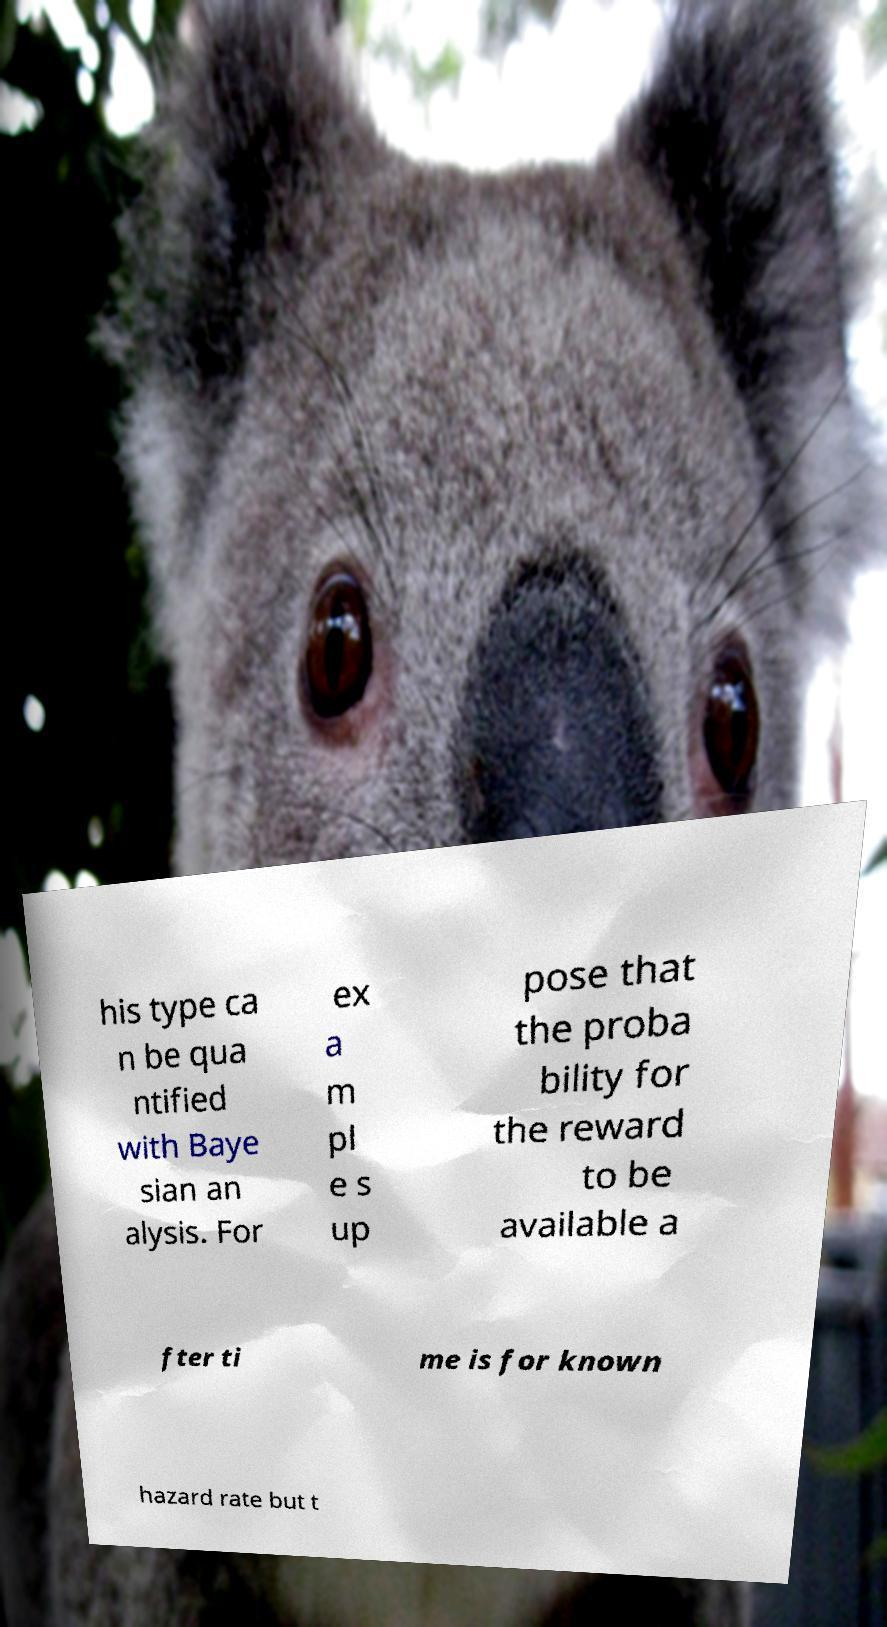I need the written content from this picture converted into text. Can you do that? his type ca n be qua ntified with Baye sian an alysis. For ex a m pl e s up pose that the proba bility for the reward to be available a fter ti me is for known hazard rate but t 